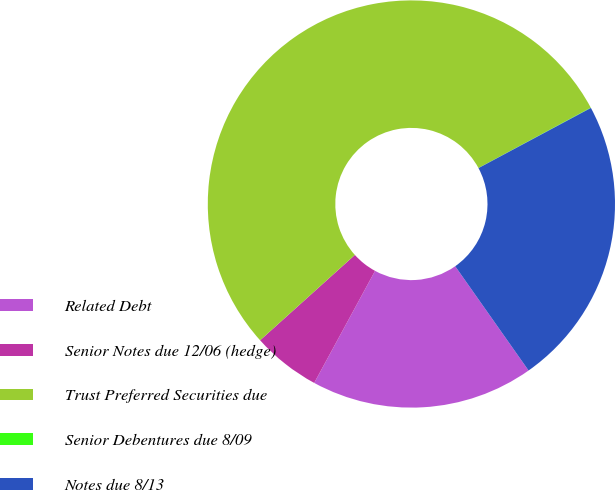<chart> <loc_0><loc_0><loc_500><loc_500><pie_chart><fcel>Related Debt<fcel>Senior Notes due 12/06 (hedge)<fcel>Trust Preferred Securities due<fcel>Senior Debentures due 8/09<fcel>Notes due 8/13<nl><fcel>17.68%<fcel>5.41%<fcel>53.82%<fcel>0.03%<fcel>23.06%<nl></chart> 